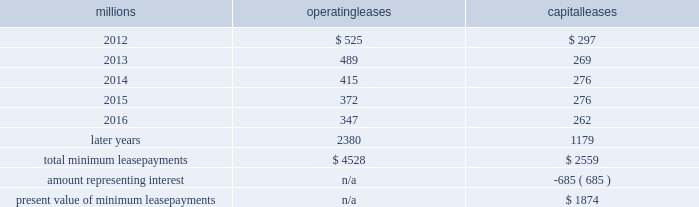The redemptions resulted in an early extinguishment charge of $ 5 million .
On march 22 , 2010 , we redeemed $ 175 million of our 6.5% ( 6.5 % ) notes due april 15 , 2012 .
The redemption resulted in an early extinguishment charge of $ 16 million in the first quarter of 2010 .
On november 1 , 2010 , we redeemed all $ 400 million of our outstanding 6.65% ( 6.65 % ) notes due january 15 , 2011 .
The redemption resulted in a $ 5 million early extinguishment charge .
Receivables securitization facility 2013 as of december 31 , 2011 and 2010 , we have recorded $ 100 million as secured debt under our receivables securitization facility .
( see further discussion of our receivables securitization facility in note 10 ) .
15 .
Variable interest entities we have entered into various lease transactions in which the structure of the leases contain variable interest entities ( vies ) .
These vies were created solely for the purpose of doing lease transactions ( principally involving railroad equipment and facilities , including our headquarters building ) and have no other activities , assets or liabilities outside of the lease transactions .
Within these lease arrangements , we have the right to purchase some or all of the assets at fixed prices .
Depending on market conditions , fixed-price purchase options available in the leases could potentially provide benefits to us ; however , these benefits are not expected to be significant .
We maintain and operate the assets based on contractual obligations within the lease arrangements , which set specific guidelines consistent within the railroad industry .
As such , we have no control over activities that could materially impact the fair value of the leased assets .
We do not hold the power to direct the activities of the vies and , therefore , do not control the ongoing activities that have a significant impact on the economic performance of the vies .
Additionally , we do not have the obligation to absorb losses of the vies or the right to receive benefits of the vies that could potentially be significant to the we are not considered to be the primary beneficiary and do not consolidate these vies because our actions and decisions do not have the most significant effect on the vie 2019s performance and our fixed-price purchase price options are not considered to be potentially significant to the vie 2019s .
The future minimum lease payments associated with the vie leases totaled $ 3.9 billion as of december 31 , 2011 .
16 .
Leases we lease certain locomotives , freight cars , and other property .
The consolidated statement of financial position as of december 31 , 2011 and 2010 included $ 2458 million , net of $ 915 million of accumulated depreciation , and $ 2520 million , net of $ 901 million of accumulated depreciation , respectively , for properties held under capital leases .
A charge to income resulting from the depreciation for assets held under capital leases is included within depreciation expense in our consolidated statements of income .
Future minimum lease payments for operating and capital leases with initial or remaining non-cancelable lease terms in excess of one year as of december 31 , 2011 , were as follows : millions operating leases capital leases .
The majority of capital lease payments relate to locomotives .
Rent expense for operating leases with terms exceeding one month was $ 637 million in 2011 , $ 624 million in 2010 , and $ 686 million in 2009 .
When cash rental payments are not made on a straight-line basis , we recognize variable rental expense on a straight-line basis over the lease term .
Contingent rentals and sub-rentals are not significant. .
What percent of total minimum operating lease payments are due in 2013? 
Computations: (489 / 4528)
Answer: 0.10799. 